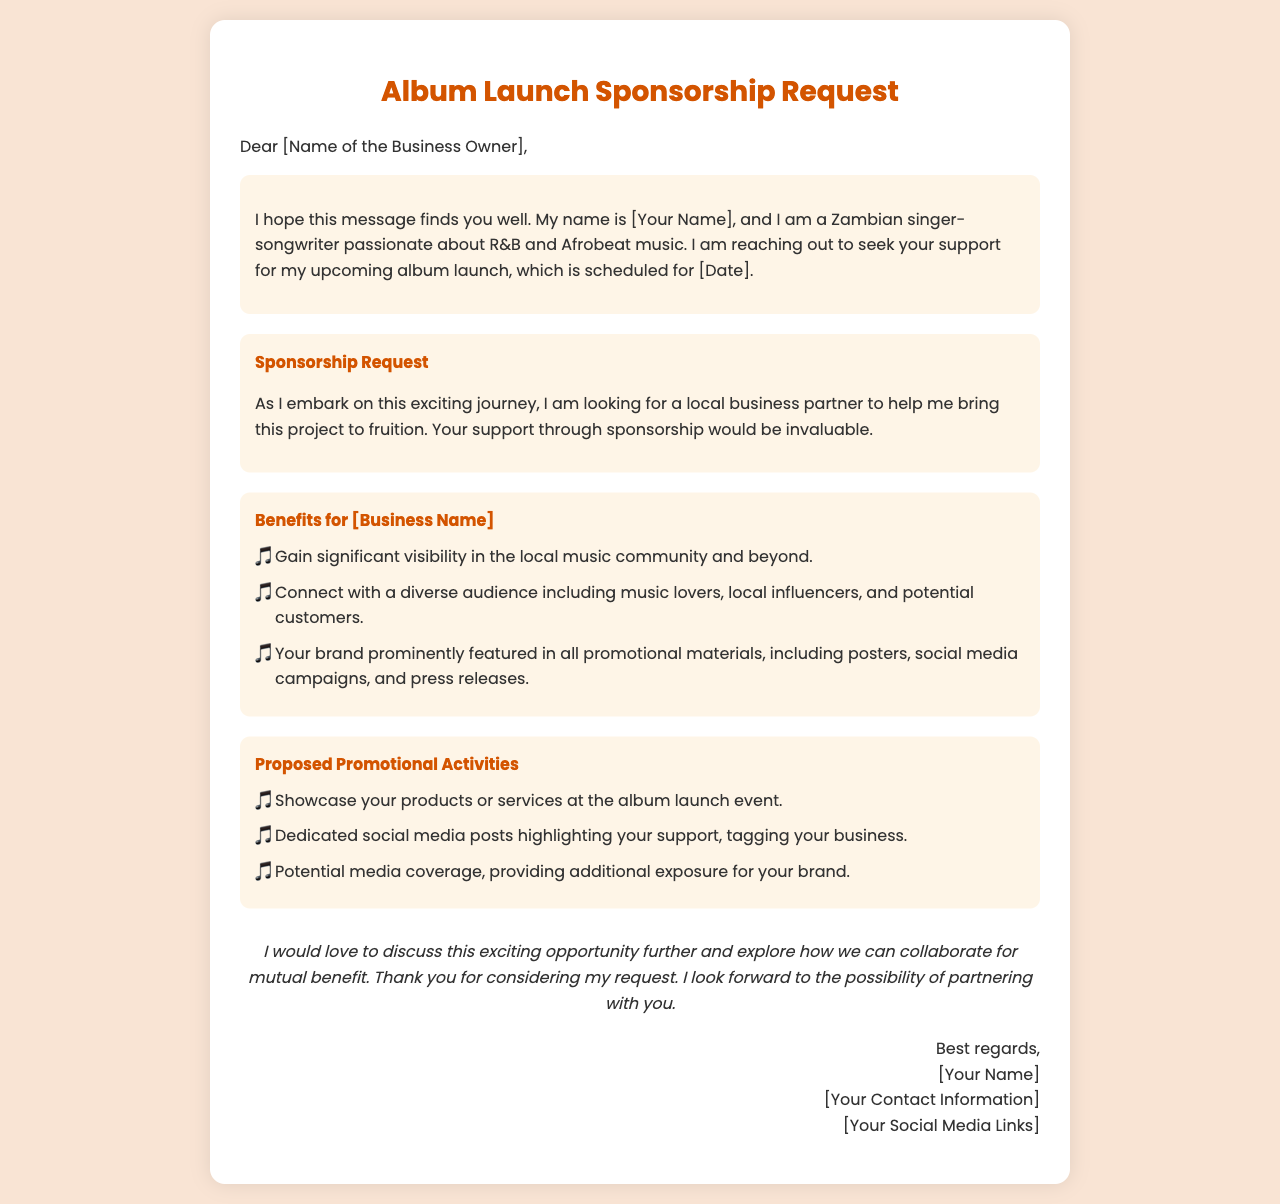What is the name of the sender? The sender's name is mentioned in the greeting of the letter as [Your Name].
Answer: [Your Name] What is the date of the album launch? The specific date of the album launch is given as [Date] in the document.
Answer: [Date] What type of music does the sender create? The type of music the sender refers to is included in the introduction, mentioning R&B and Afrobeat.
Answer: R&B and Afrobeat What benefits does the sponsor receive? The document lists several benefits, one of which is "Gain significant visibility in the local music community and beyond."
Answer: Gain significant visibility How many promotional activities are proposed? Three promotional activities are specifically mentioned in the document.
Answer: Three What is the purpose of the letter? The primary purpose of the letter is outlined as a request for sponsorship to support the album launch.
Answer: Request for sponsorship What kind of audience will the sponsor connect with? The audience that the sponsor may connect with is described as music lovers, local influencers, and potential customers.
Answer: Music lovers, local influencers, and potential customers What is the tone of the closing paragraph? The tone in the closing paragraph reflects a hopeful and inviting nature towards potential collaboration.
Answer: Hopeful and inviting 